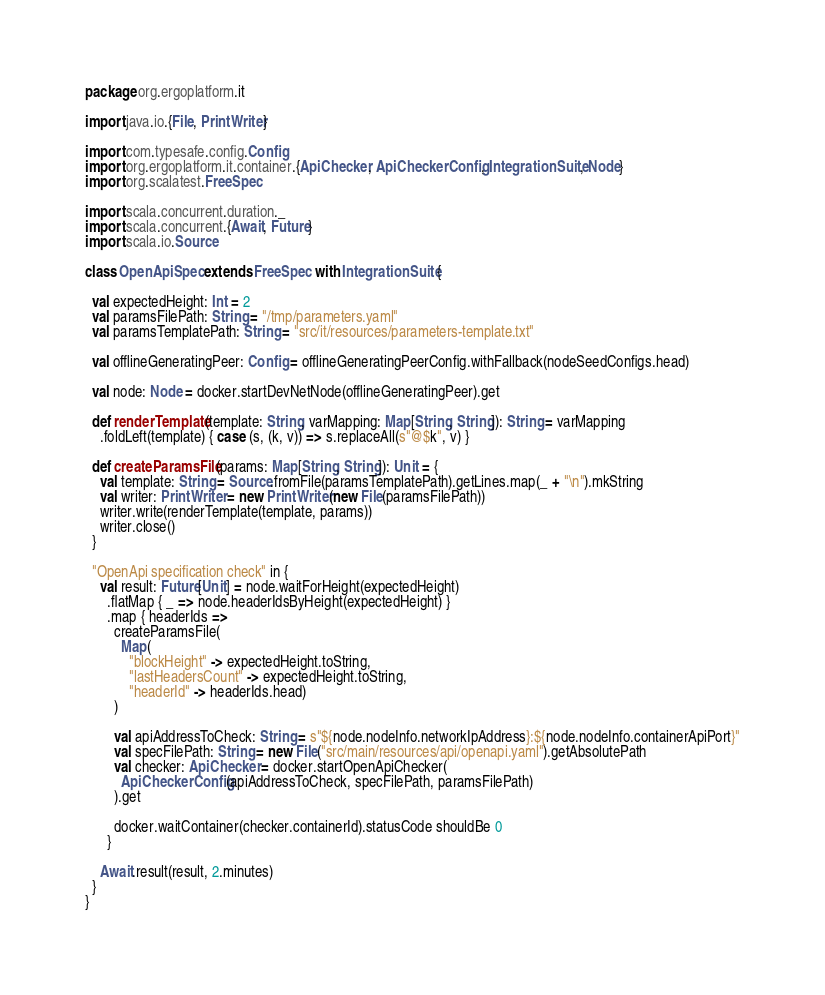Convert code to text. <code><loc_0><loc_0><loc_500><loc_500><_Scala_>package org.ergoplatform.it

import java.io.{File, PrintWriter}

import com.typesafe.config.Config
import org.ergoplatform.it.container.{ApiChecker, ApiCheckerConfig, IntegrationSuite, Node}
import org.scalatest.FreeSpec

import scala.concurrent.duration._
import scala.concurrent.{Await, Future}
import scala.io.Source

class OpenApiSpec extends FreeSpec with IntegrationSuite {

  val expectedHeight: Int = 2
  val paramsFilePath: String = "/tmp/parameters.yaml"
  val paramsTemplatePath: String = "src/it/resources/parameters-template.txt"

  val offlineGeneratingPeer: Config = offlineGeneratingPeerConfig.withFallback(nodeSeedConfigs.head)

  val node: Node = docker.startDevNetNode(offlineGeneratingPeer).get

  def renderTemplate(template: String, varMapping: Map[String, String]): String = varMapping
    .foldLeft(template) { case (s, (k, v)) => s.replaceAll(s"@$k", v) }

  def createParamsFile(params: Map[String, String]): Unit = {
    val template: String = Source.fromFile(paramsTemplatePath).getLines.map(_ + "\n").mkString
    val writer: PrintWriter = new PrintWriter(new File(paramsFilePath))
    writer.write(renderTemplate(template, params))
    writer.close()
  }

  "OpenApi specification check" in {
    val result: Future[Unit] = node.waitForHeight(expectedHeight)
      .flatMap { _ => node.headerIdsByHeight(expectedHeight) }
      .map { headerIds =>
        createParamsFile(
          Map(
            "blockHeight" -> expectedHeight.toString,
            "lastHeadersCount" -> expectedHeight.toString,
            "headerId" -> headerIds.head)
        )

        val apiAddressToCheck: String = s"${node.nodeInfo.networkIpAddress}:${node.nodeInfo.containerApiPort}"
        val specFilePath: String = new File("src/main/resources/api/openapi.yaml").getAbsolutePath
        val checker: ApiChecker = docker.startOpenApiChecker(
          ApiCheckerConfig(apiAddressToCheck, specFilePath, paramsFilePath)
        ).get

        docker.waitContainer(checker.containerId).statusCode shouldBe 0
      }

    Await.result(result, 2.minutes)
  }
}
</code> 